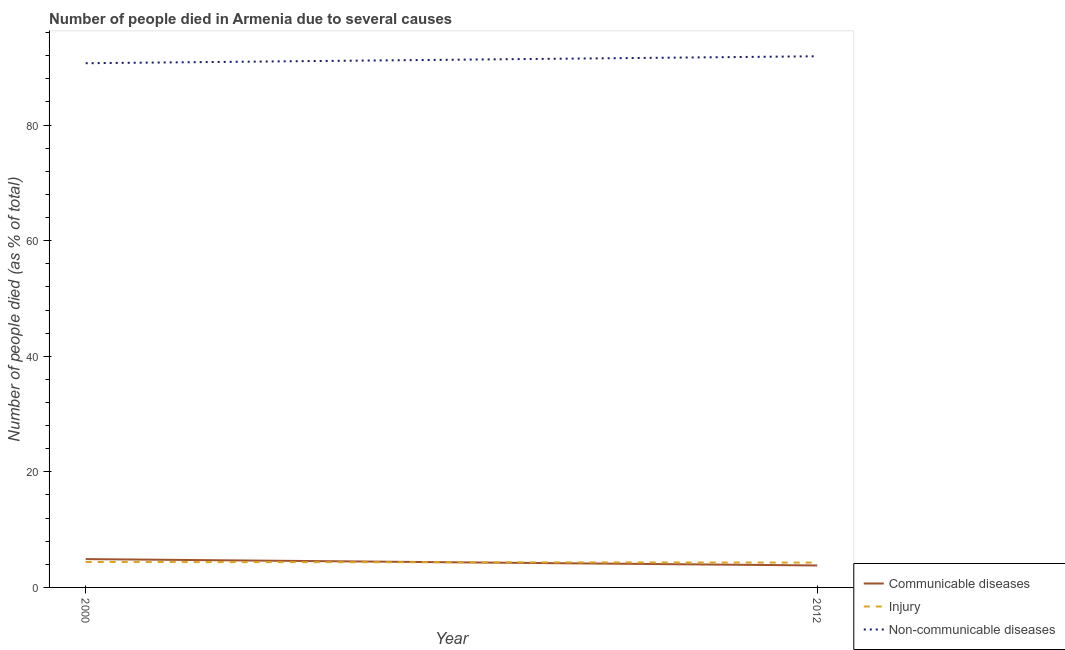Across all years, what is the maximum number of people who dies of non-communicable diseases?
Your response must be concise. 91.9. Across all years, what is the minimum number of people who died of injury?
Make the answer very short. 4.3. In which year was the number of people who died of injury maximum?
Provide a short and direct response. 2000. What is the difference between the number of people who died of communicable diseases in 2000 and that in 2012?
Make the answer very short. 1.1. What is the difference between the number of people who died of communicable diseases in 2012 and the number of people who died of injury in 2000?
Your answer should be very brief. -0.6. What is the average number of people who died of injury per year?
Your answer should be very brief. 4.35. In the year 2012, what is the difference between the number of people who dies of non-communicable diseases and number of people who died of communicable diseases?
Provide a succinct answer. 88.1. In how many years, is the number of people who died of communicable diseases greater than 36 %?
Offer a very short reply. 0. What is the ratio of the number of people who died of injury in 2000 to that in 2012?
Offer a very short reply. 1.02. Is the number of people who died of communicable diseases in 2000 less than that in 2012?
Ensure brevity in your answer.  No. In how many years, is the number of people who dies of non-communicable diseases greater than the average number of people who dies of non-communicable diseases taken over all years?
Provide a short and direct response. 1. Is the number of people who dies of non-communicable diseases strictly less than the number of people who died of injury over the years?
Keep it short and to the point. No. What is the difference between two consecutive major ticks on the Y-axis?
Keep it short and to the point. 20. Are the values on the major ticks of Y-axis written in scientific E-notation?
Your response must be concise. No. Does the graph contain any zero values?
Provide a short and direct response. No. Does the graph contain grids?
Provide a succinct answer. No. Where does the legend appear in the graph?
Your answer should be very brief. Bottom right. How are the legend labels stacked?
Offer a terse response. Vertical. What is the title of the graph?
Your response must be concise. Number of people died in Armenia due to several causes. What is the label or title of the X-axis?
Give a very brief answer. Year. What is the label or title of the Y-axis?
Ensure brevity in your answer.  Number of people died (as % of total). What is the Number of people died (as % of total) in Communicable diseases in 2000?
Provide a short and direct response. 4.9. What is the Number of people died (as % of total) in Non-communicable diseases in 2000?
Offer a very short reply. 90.7. What is the Number of people died (as % of total) in Communicable diseases in 2012?
Your answer should be compact. 3.8. What is the Number of people died (as % of total) in Injury in 2012?
Your answer should be compact. 4.3. What is the Number of people died (as % of total) in Non-communicable diseases in 2012?
Your answer should be very brief. 91.9. Across all years, what is the maximum Number of people died (as % of total) of Communicable diseases?
Make the answer very short. 4.9. Across all years, what is the maximum Number of people died (as % of total) of Non-communicable diseases?
Provide a short and direct response. 91.9. Across all years, what is the minimum Number of people died (as % of total) in Communicable diseases?
Your answer should be compact. 3.8. Across all years, what is the minimum Number of people died (as % of total) in Injury?
Give a very brief answer. 4.3. Across all years, what is the minimum Number of people died (as % of total) of Non-communicable diseases?
Provide a short and direct response. 90.7. What is the total Number of people died (as % of total) in Injury in the graph?
Offer a terse response. 8.7. What is the total Number of people died (as % of total) of Non-communicable diseases in the graph?
Provide a short and direct response. 182.6. What is the difference between the Number of people died (as % of total) of Injury in 2000 and that in 2012?
Provide a short and direct response. 0.1. What is the difference between the Number of people died (as % of total) in Non-communicable diseases in 2000 and that in 2012?
Your answer should be very brief. -1.2. What is the difference between the Number of people died (as % of total) in Communicable diseases in 2000 and the Number of people died (as % of total) in Injury in 2012?
Keep it short and to the point. 0.6. What is the difference between the Number of people died (as % of total) in Communicable diseases in 2000 and the Number of people died (as % of total) in Non-communicable diseases in 2012?
Provide a succinct answer. -87. What is the difference between the Number of people died (as % of total) of Injury in 2000 and the Number of people died (as % of total) of Non-communicable diseases in 2012?
Offer a terse response. -87.5. What is the average Number of people died (as % of total) of Communicable diseases per year?
Make the answer very short. 4.35. What is the average Number of people died (as % of total) in Injury per year?
Provide a succinct answer. 4.35. What is the average Number of people died (as % of total) of Non-communicable diseases per year?
Give a very brief answer. 91.3. In the year 2000, what is the difference between the Number of people died (as % of total) in Communicable diseases and Number of people died (as % of total) in Non-communicable diseases?
Your answer should be very brief. -85.8. In the year 2000, what is the difference between the Number of people died (as % of total) in Injury and Number of people died (as % of total) in Non-communicable diseases?
Give a very brief answer. -86.3. In the year 2012, what is the difference between the Number of people died (as % of total) in Communicable diseases and Number of people died (as % of total) in Non-communicable diseases?
Your answer should be very brief. -88.1. In the year 2012, what is the difference between the Number of people died (as % of total) in Injury and Number of people died (as % of total) in Non-communicable diseases?
Your answer should be compact. -87.6. What is the ratio of the Number of people died (as % of total) in Communicable diseases in 2000 to that in 2012?
Offer a terse response. 1.29. What is the ratio of the Number of people died (as % of total) of Injury in 2000 to that in 2012?
Your response must be concise. 1.02. What is the ratio of the Number of people died (as % of total) of Non-communicable diseases in 2000 to that in 2012?
Your answer should be compact. 0.99. What is the difference between the highest and the second highest Number of people died (as % of total) of Communicable diseases?
Ensure brevity in your answer.  1.1. What is the difference between the highest and the second highest Number of people died (as % of total) in Injury?
Your response must be concise. 0.1. What is the difference between the highest and the lowest Number of people died (as % of total) of Communicable diseases?
Your response must be concise. 1.1. 